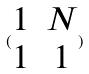<formula> <loc_0><loc_0><loc_500><loc_500>( \begin{matrix} 1 & N \\ 1 & 1 \end{matrix} )</formula> 